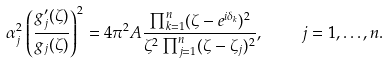Convert formula to latex. <formula><loc_0><loc_0><loc_500><loc_500>\alpha _ { j } ^ { 2 } \left ( \frac { g ^ { \prime } _ { j } ( \zeta ) } { g _ { j } ( \zeta ) } \right ) ^ { 2 } = 4 \pi ^ { 2 } A \frac { \prod _ { k = 1 } ^ { n } ( \zeta - e ^ { i \delta _ { k } } ) ^ { 2 } } { \zeta ^ { 2 } \prod _ { j = 1 } ^ { n } ( \zeta - \zeta _ { j } ) ^ { 2 } } , \quad j = 1 , \dots , n .</formula> 